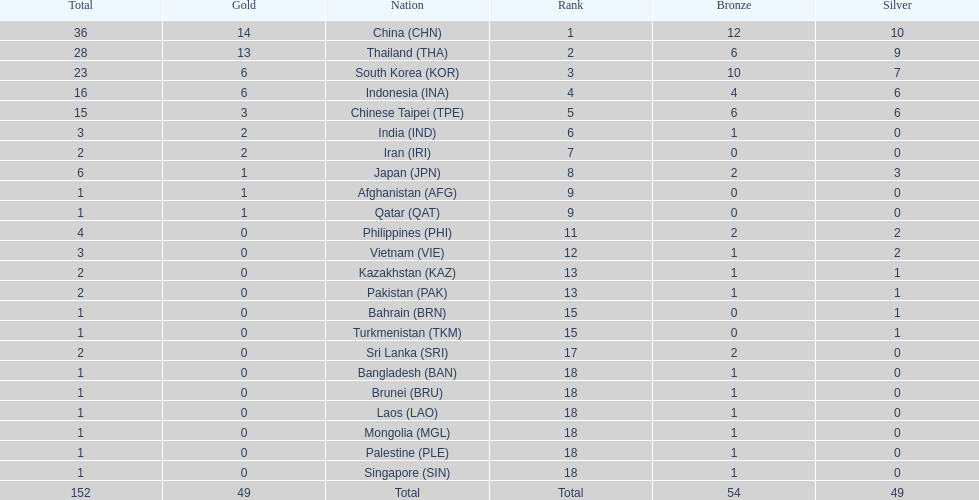How many nations received a medal in each gold, silver, and bronze? 6. 